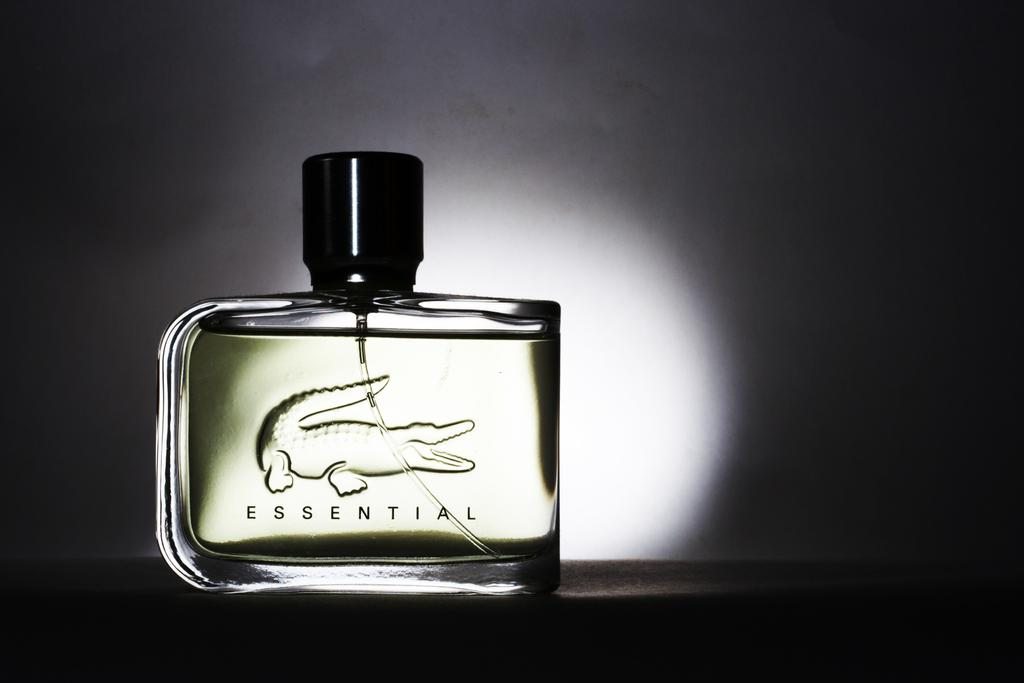Provide a one-sentence caption for the provided image. A bottle of men's cologne called Essential with a crocodile on it. 